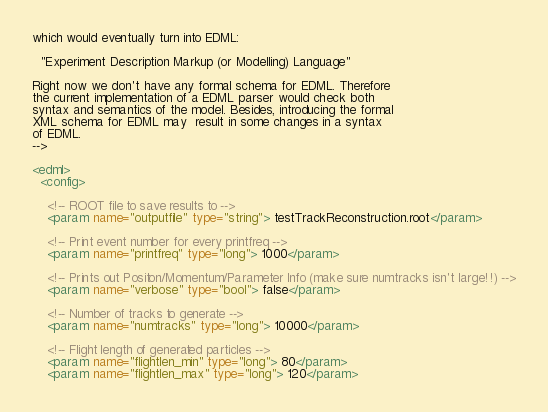<code> <loc_0><loc_0><loc_500><loc_500><_XML_>which would eventually turn into EDML:
 
  "Experiment Description Markup (or Modelling) Language"
 
Right now we don't have any formal schema for EDML. Therefore
the current implementation of a EDML parser would check both
syntax and semantics of the model. Besides, introducing the formal
XML schema for EDML may  result in some changes in a syntax
of EDML.
-->
 
<edml>
  <config>

    <!-- ROOT file to save results to -->
    <param name="outputfile" type="string"> testTrackReconstruction.root</param>

    <!-- Print event number for every printfreq -->
    <param name="printfreq" type="long"> 1000</param>

    <!-- Prints out Positon/Momentum/Parameter Info (make sure numtracks isn't large!!) -->
    <param name="verbose" type="bool"> false</param>

    <!-- Number of tracks to generate -->
    <param name="numtracks" type="long"> 10000</param>

    <!-- Flight length of generated particles -->
    <param name="flightlen_min" type="long"> 80</param>
    <param name="flightlen_max" type="long"> 120</param></code> 